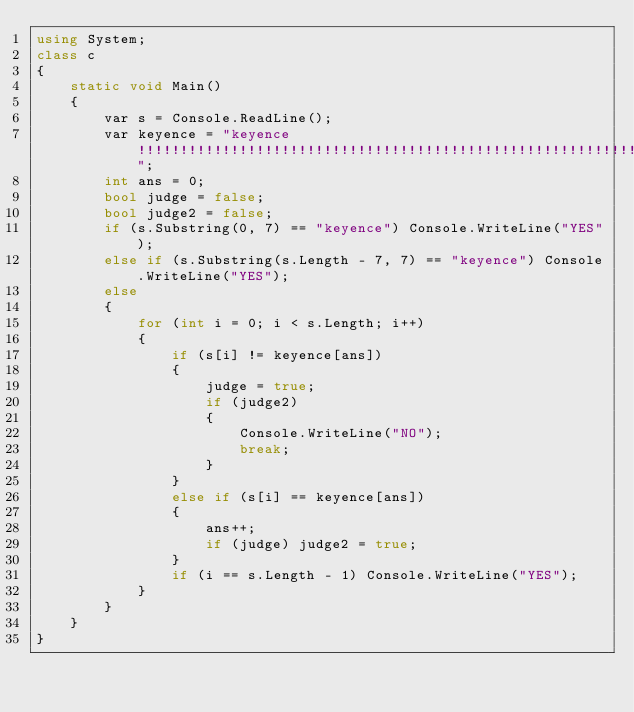Convert code to text. <code><loc_0><loc_0><loc_500><loc_500><_C#_>using System;
class c
{
    static void Main()
    {
        var s = Console.ReadLine();
        var keyence = "keyence!!!!!!!!!!!!!!!!!!!!!!!!!!!!!!!!!!!!!!!!!!!!!!!!!!!!!!!!!!!!!!!!!!!!!!!!!!!!!!!!!!!!!!!!!!!!!!!!!!!!!!!!!!!!!!!!!!!!!!!!!!!!!!!!!!!!!!!!!!!!!!";
        int ans = 0;
        bool judge = false;
        bool judge2 = false;
        if (s.Substring(0, 7) == "keyence") Console.WriteLine("YES");
        else if (s.Substring(s.Length - 7, 7) == "keyence") Console.WriteLine("YES");
        else
        {
            for (int i = 0; i < s.Length; i++)
            {
                if (s[i] != keyence[ans])
                {
                    judge = true;
                    if (judge2)
                    {
                        Console.WriteLine("NO");
                        break;
                    }
                }
                else if (s[i] == keyence[ans])
                {
                    ans++;
                    if (judge) judge2 = true;
                }
                if (i == s.Length - 1) Console.WriteLine("YES");
            }
        }
    }
}</code> 